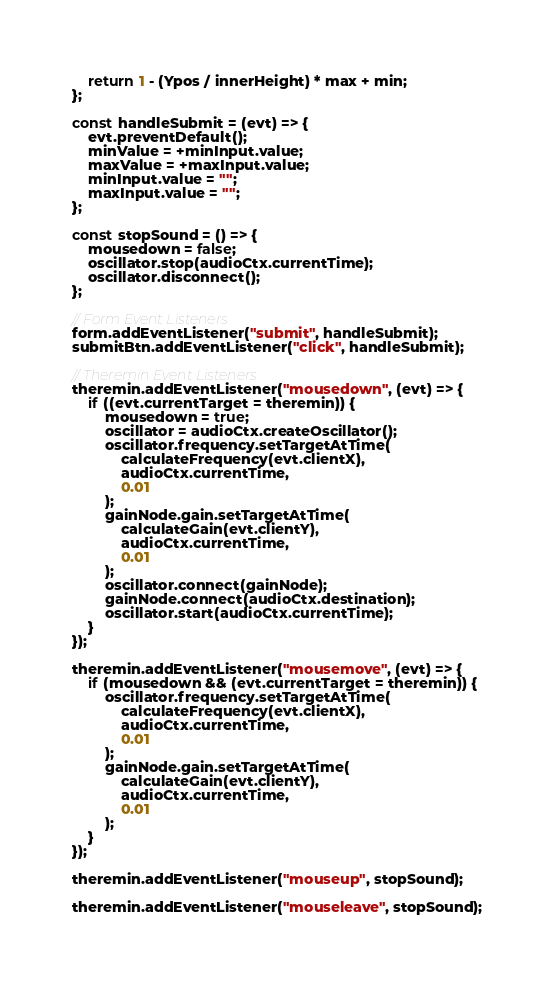Convert code to text. <code><loc_0><loc_0><loc_500><loc_500><_JavaScript_>	return 1 - (Ypos / innerHeight) * max + min;
};

const handleSubmit = (evt) => {
	evt.preventDefault();
	minValue = +minInput.value;
	maxValue = +maxInput.value;
	minInput.value = "";
	maxInput.value = "";
};

const stopSound = () => {
	mousedown = false;
	oscillator.stop(audioCtx.currentTime);
	oscillator.disconnect();
};

// Form Event Listeners
form.addEventListener("submit", handleSubmit);
submitBtn.addEventListener("click", handleSubmit);

// Theremin Event Listeners
theremin.addEventListener("mousedown", (evt) => {
	if ((evt.currentTarget = theremin)) {
		mousedown = true;
		oscillator = audioCtx.createOscillator();
		oscillator.frequency.setTargetAtTime(
			calculateFrequency(evt.clientX),
			audioCtx.currentTime,
			0.01
		);
		gainNode.gain.setTargetAtTime(
			calculateGain(evt.clientY),
			audioCtx.currentTime,
			0.01
		);
		oscillator.connect(gainNode);
		gainNode.connect(audioCtx.destination);
		oscillator.start(audioCtx.currentTime);
	}
});

theremin.addEventListener("mousemove", (evt) => {
	if (mousedown && (evt.currentTarget = theremin)) {
		oscillator.frequency.setTargetAtTime(
			calculateFrequency(evt.clientX),
			audioCtx.currentTime,
			0.01
		);
		gainNode.gain.setTargetAtTime(
			calculateGain(evt.clientY),
			audioCtx.currentTime,
			0.01
		);
	}
});

theremin.addEventListener("mouseup", stopSound);

theremin.addEventListener("mouseleave", stopSound);
</code> 